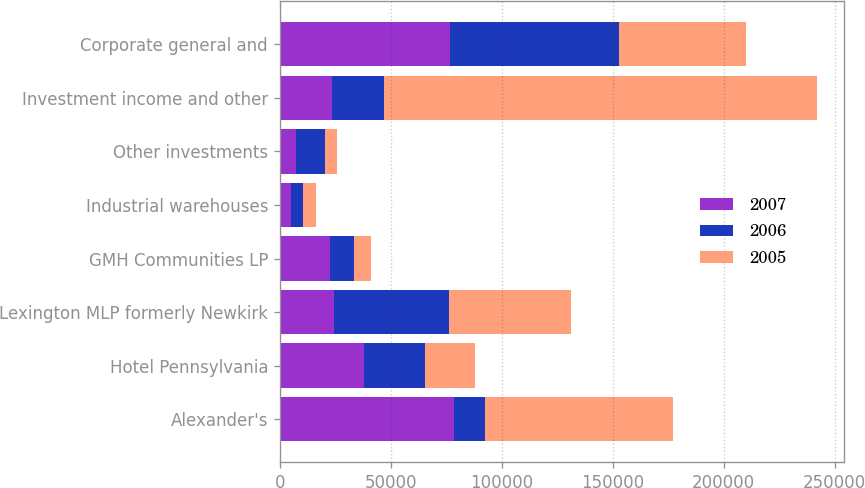Convert chart to OTSL. <chart><loc_0><loc_0><loc_500><loc_500><stacked_bar_chart><ecel><fcel>Alexander's<fcel>Hotel Pennsylvania<fcel>Lexington MLP formerly Newkirk<fcel>GMH Communities LP<fcel>Industrial warehouses<fcel>Other investments<fcel>Investment income and other<fcel>Corporate general and<nl><fcel>2007<fcel>78375<fcel>37941<fcel>24539<fcel>22604<fcel>4881<fcel>7322<fcel>23571.5<fcel>76799<nl><fcel>2006<fcel>14130<fcel>27495<fcel>51737<fcel>10737<fcel>5582<fcel>13253<fcel>23571.5<fcel>76071<nl><fcel>2005<fcel>84874<fcel>22522<fcel>55126<fcel>7955<fcel>5666<fcel>5319<fcel>194851<fcel>57221<nl></chart> 